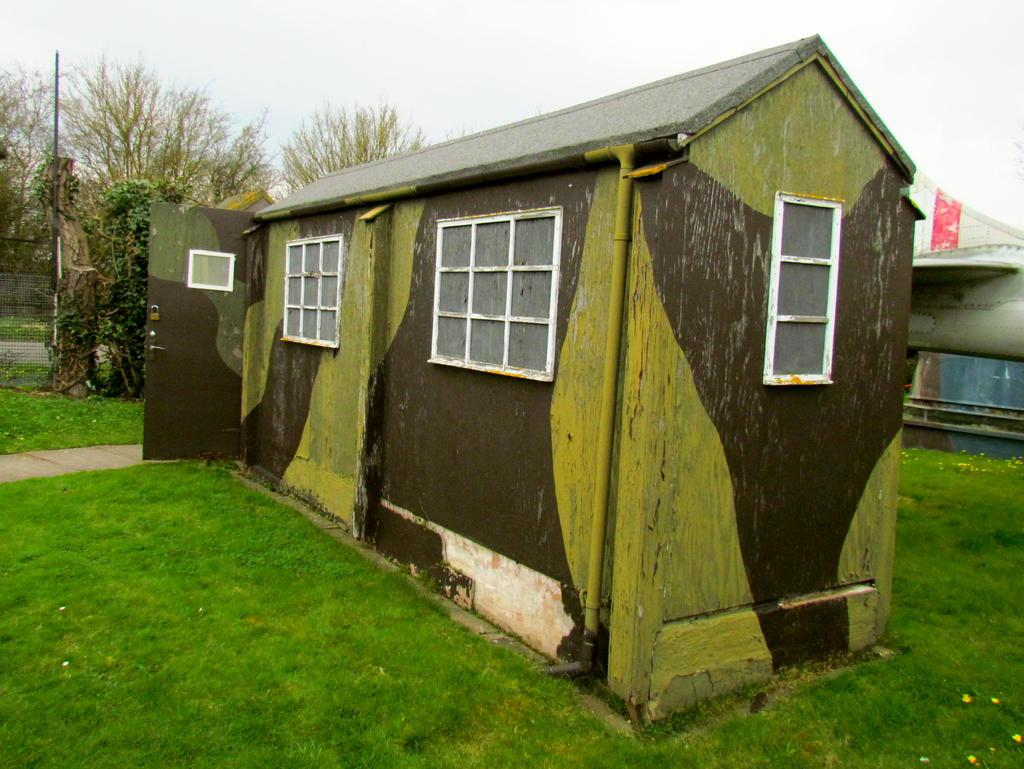What type of vegetation can be seen in the image? There is grass in the image. What other natural elements are present in the image? There are trees in the image. What type of structure is visible in the image? There is a green-colored shack in the image. What is the tall, vertical object in the image? There is a pole in the image. What can be seen on the right side of the image? There are unspecified objects on the right side of the image. How many cows are present on the farm in the image? There is no farm or cows present in the image. What type of shock can be seen in the image? There is no shock or any indication of an electrical or emotional shock in the image. 